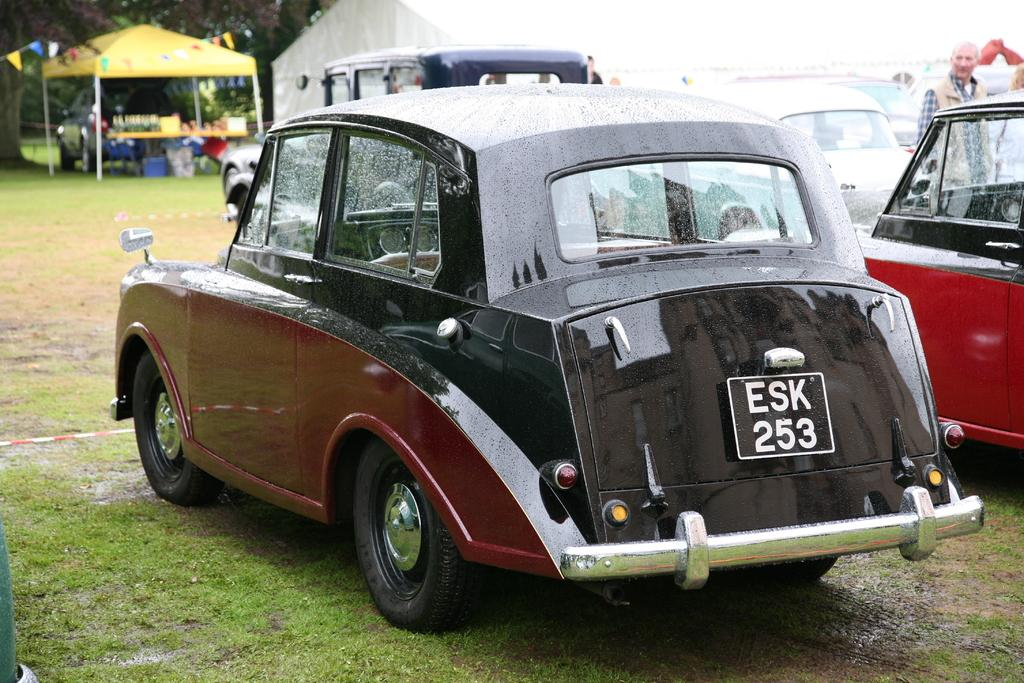What type of vehicles are present in the image? There are cars in the image. Can you describe the colors of the cars? One car is red in color, and another car is black and red in color. Who or what else can be seen in the image? There is a man standing in the image, and there are tents present as well. What is the ground covered with in the image? The ground is covered with grass in the image. How many sacks of sugar are visible in the image? There are no sacks of sugar present in the image. What type of fruit is being held by the man in the image? The image does not show the man holding any fruit, including apples. 